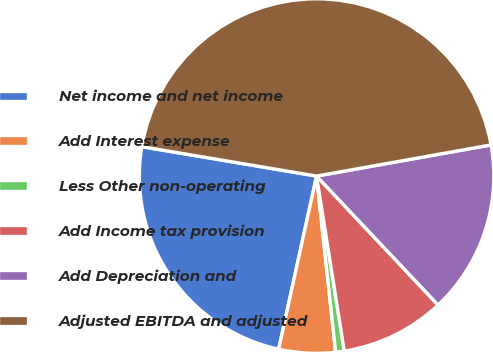Convert chart. <chart><loc_0><loc_0><loc_500><loc_500><pie_chart><fcel>Net income and net income<fcel>Add Interest expense<fcel>Less Other non-operating<fcel>Add Income tax provision<fcel>Add Depreciation and<fcel>Adjusted EBITDA and adjusted<nl><fcel>24.22%<fcel>5.15%<fcel>0.78%<fcel>9.53%<fcel>15.78%<fcel>44.53%<nl></chart> 